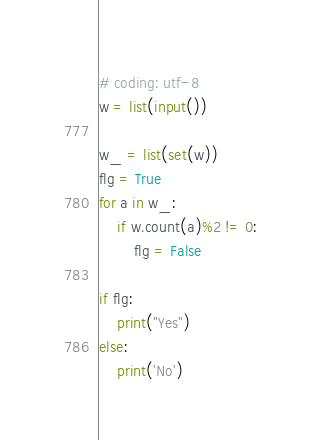Convert code to text. <code><loc_0><loc_0><loc_500><loc_500><_Python_># coding: utf-8
w = list(input())

w_ = list(set(w))
flg = True
for a in w_:
    if w.count(a)%2 != 0:
        flg = False

if flg:
    print("Yes")
else:
    print('No')</code> 